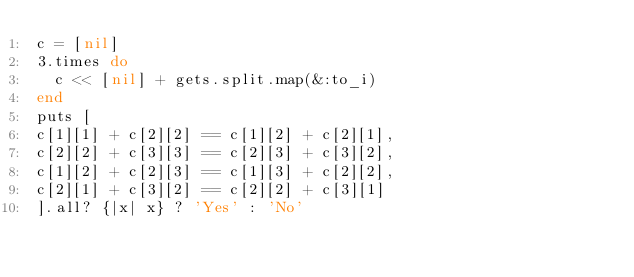<code> <loc_0><loc_0><loc_500><loc_500><_Ruby_>c = [nil]
3.times do
  c << [nil] + gets.split.map(&:to_i)
end
puts [
c[1][1] + c[2][2] == c[1][2] + c[2][1],
c[2][2] + c[3][3] == c[2][3] + c[3][2],
c[1][2] + c[2][3] == c[1][3] + c[2][2],
c[2][1] + c[3][2] == c[2][2] + c[3][1]
].all? {|x| x} ? 'Yes' : 'No'
</code> 